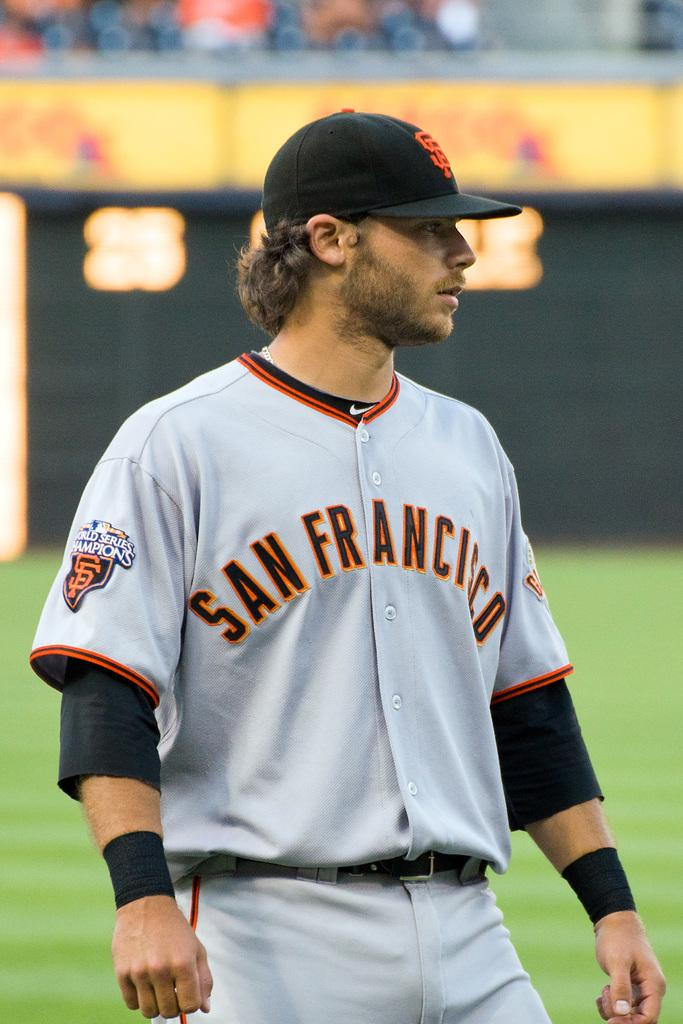<image>
Create a compact narrative representing the image presented. A man in a uniform that has San Francisco on the front. 